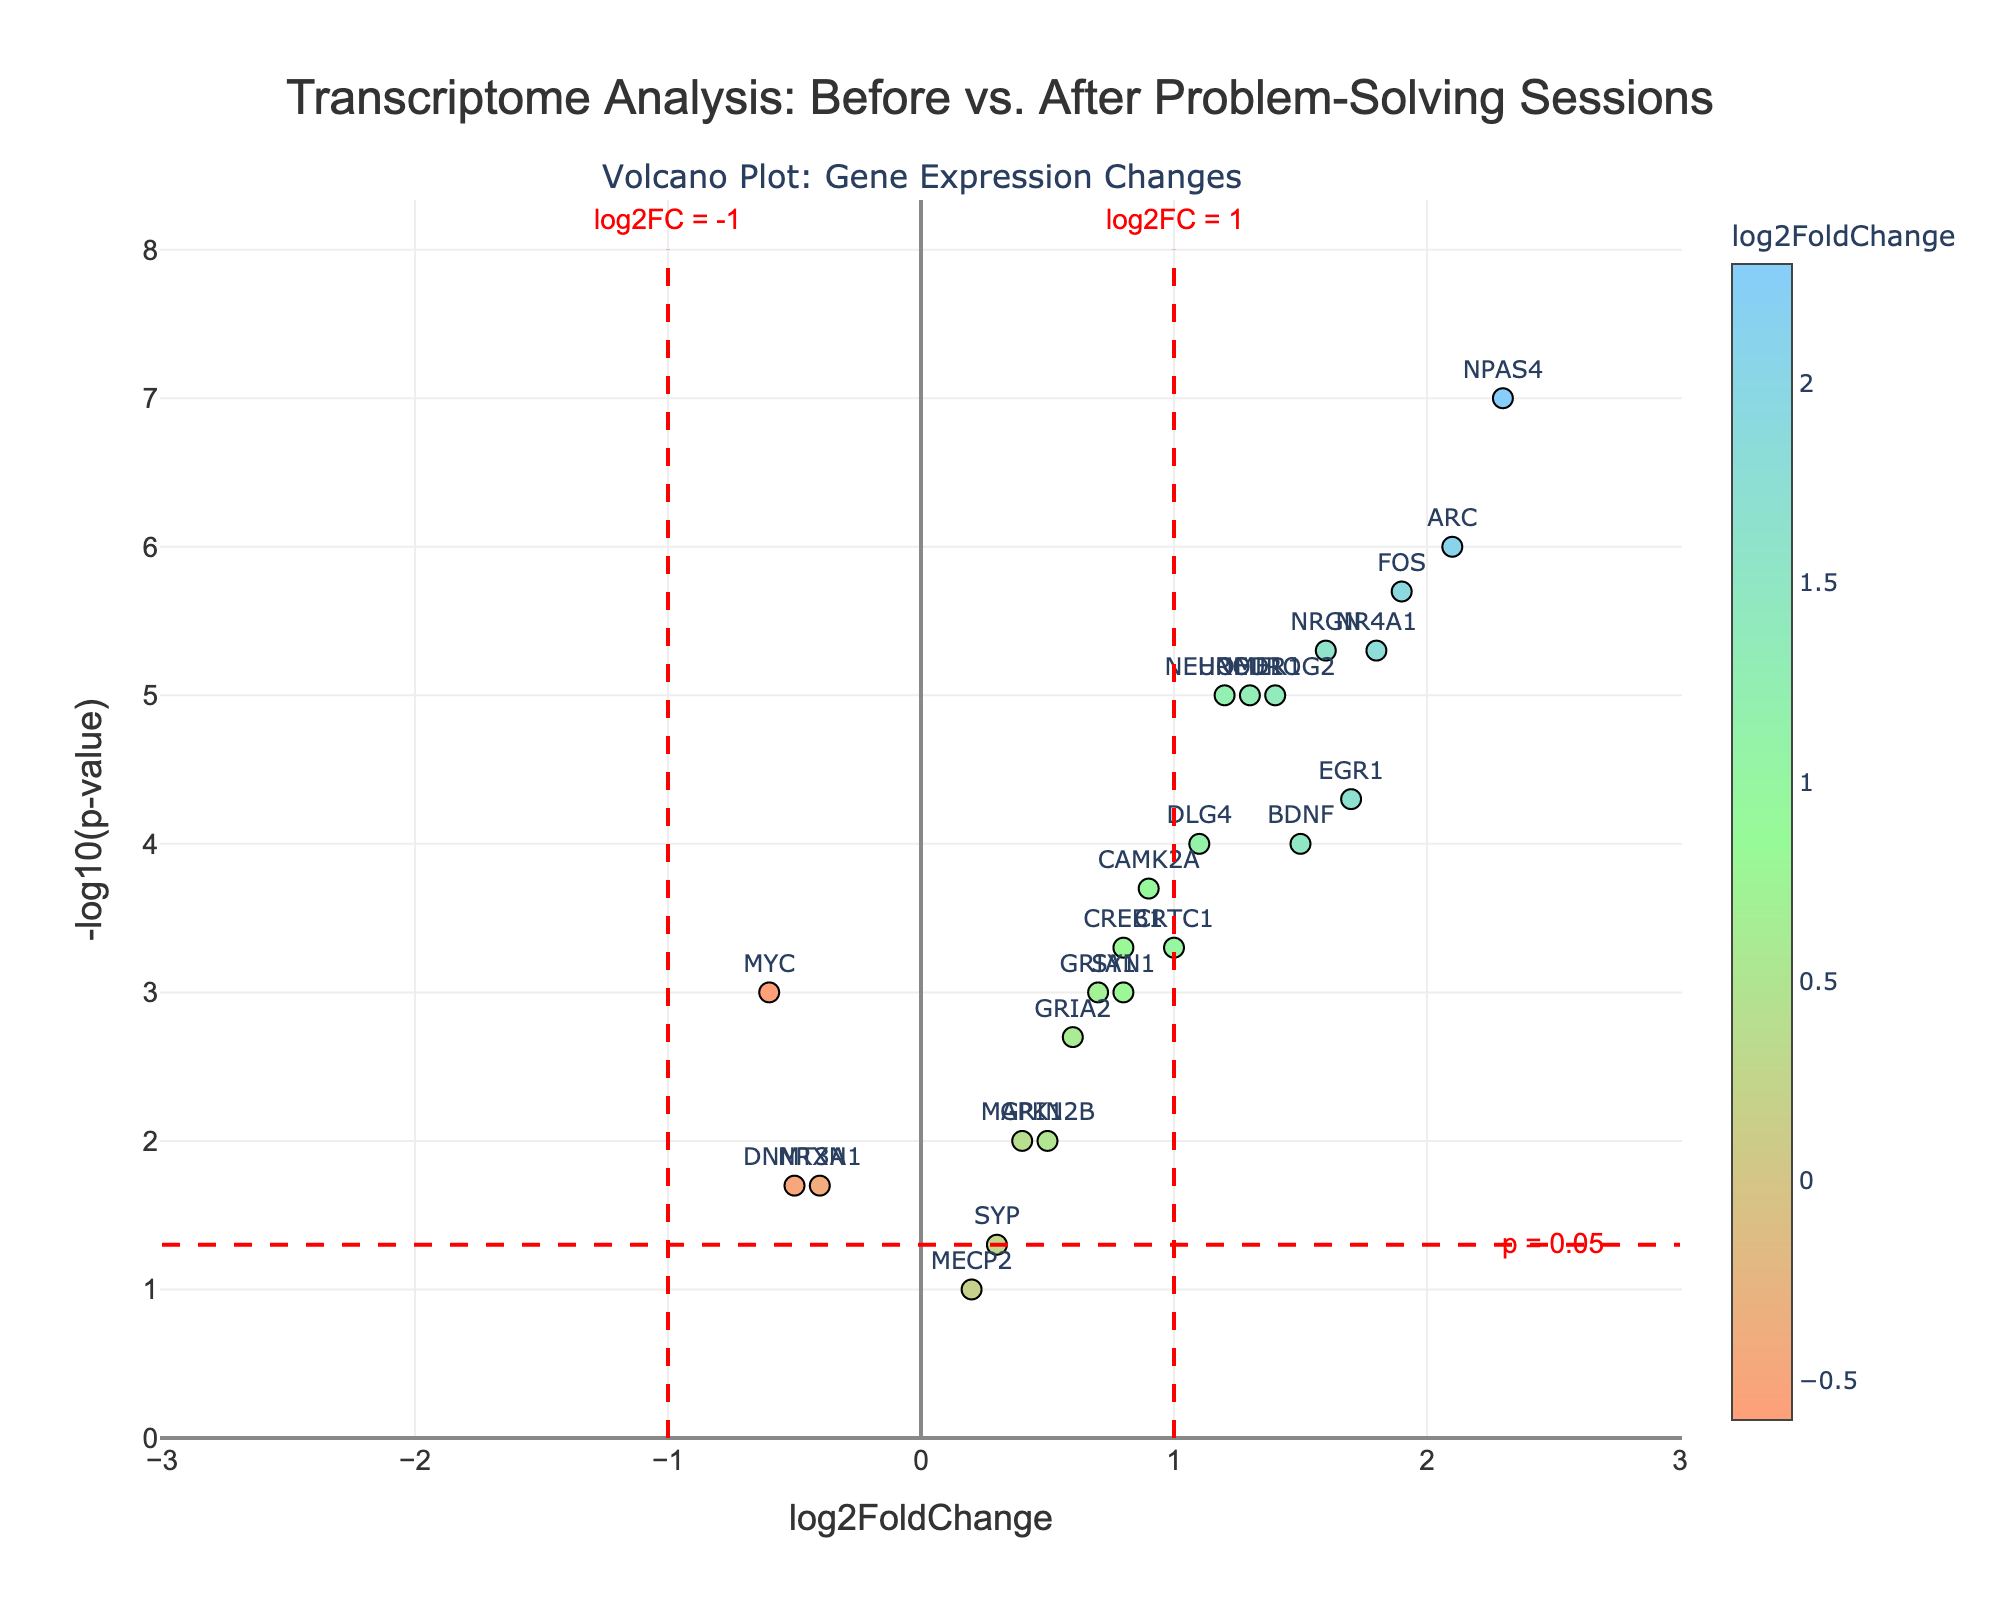What is the title of the figure? The title of the figure is displayed at the top in a larger font size and bold style in the plot.
Answer: Transcriptome Analysis: Before vs. After Problem-Solving Sessions How many genes have a log2FoldChange greater than 1? To find this, look for the points on the plot with a log2FoldChange value greater than 1 on the x-axis. Count these points.
Answer: 9 Which gene has the highest log2FoldChange value? Checking the plot's x-axis values, the gene with the farthest positive log2FoldChange value is identified.
Answer: NPAS4 How many genes exhibit a significant change in expression with p-value less than 0.05? Genes with significant changes are found above the horizontal threshold line at -log10(p-value) = 1.3. Count the points above this line.
Answer: 18 Which gene has the lowest p-value, and what is its -log10(p-value) value? The gene with the smallest p-value will be at the highest y-axis point. Identify this point and read its y-axis value.
Answer: NPAS4, 7.0 How has the expression level of the gene MYC changed? Find MYC on the plot and check whether its log2FoldChange value is positive or negative on the x-axis.
Answer: Decreased (-0.6) How many genes have both log2FoldChange greater than 1 and -log10(p-value) greater than 2? Locate the points that satisfy both criteria by searching in the top-right area of the plot. Count these points.
Answer: 6 Which genes are located between the log2FoldChange values of -1 and 1 on the x-axis and above the significance threshold? Identify the points between -1 and 1 on the x-axis and above the red dashed horizontal line indicating p = 0.05.
Answer: GRIN2B, SYP, NRXN1, MAPK1, DNMT3A, MECP2 Of the genes with significant positive fold changes, which has the smallest -log10(p-value)? Look at the points on the positive side of the x-axis (right side) and determine which one has the lowest y-axis position above the significance threshold.
Answer: GRIN2B 